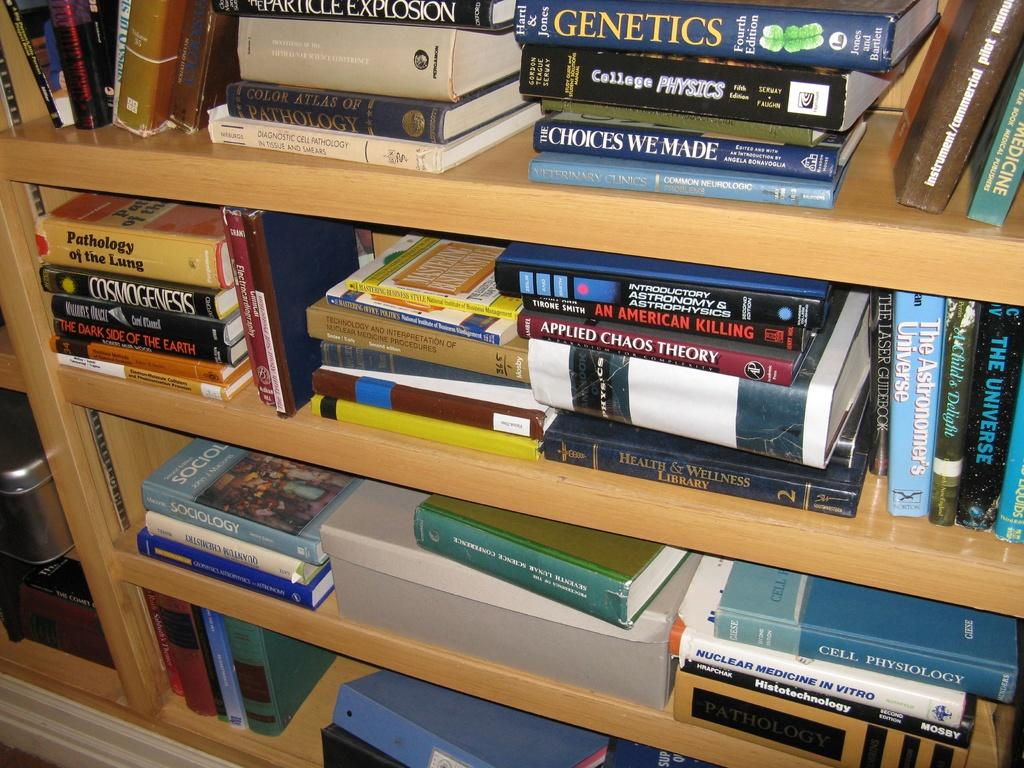<image>
Offer a succinct explanation of the picture presented. Several books on genetics are stacked on shelves. 